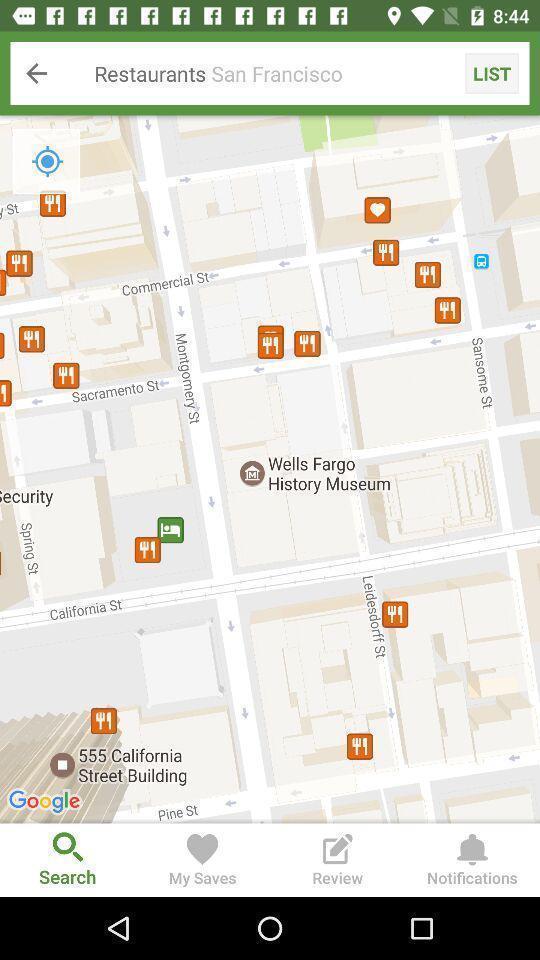Describe the content in this image. Screen displaying various restaurant locations. 